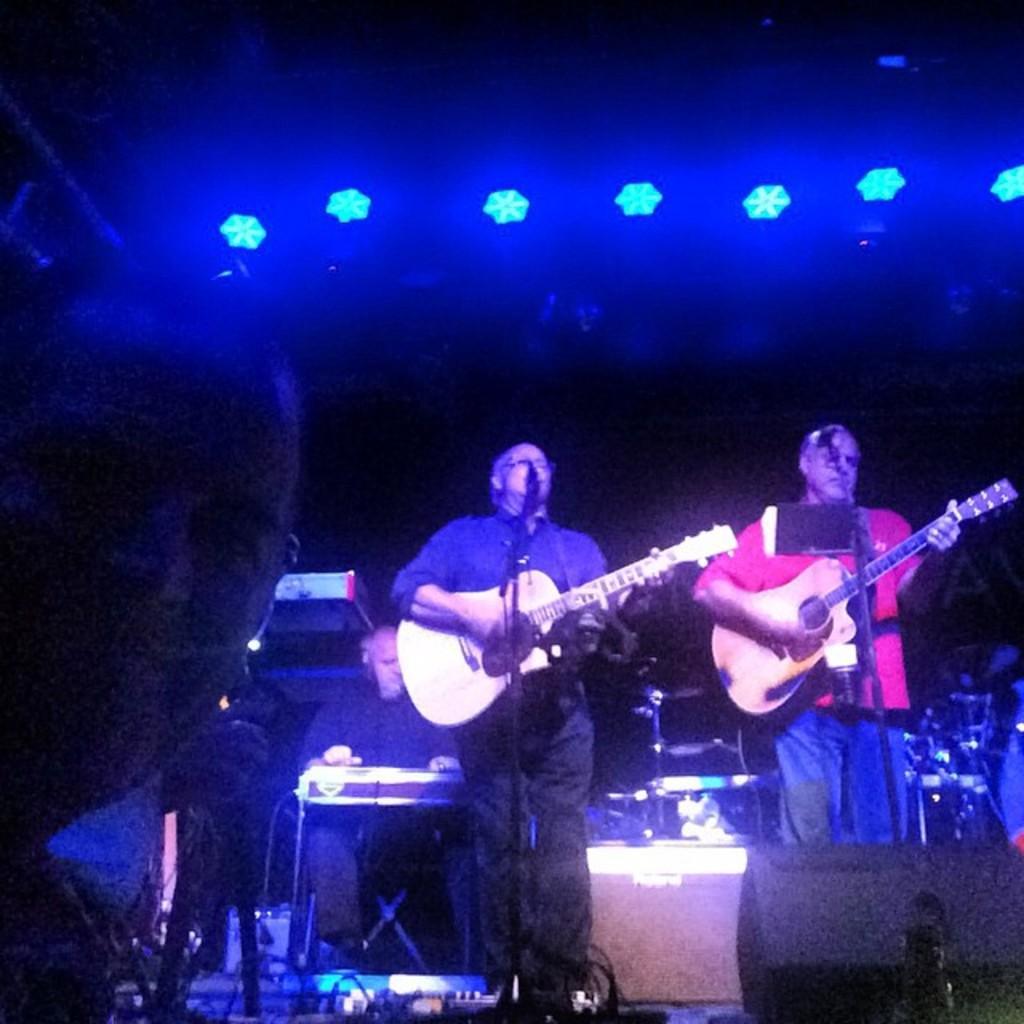Describe this image in one or two sentences. In this image on the right side a person holding a guitar and wearing a red color t- shirt,in front of him there is a mike. And beside him on the middle of the image there is a person holding a guitar and wearing a blue color shirt ,in front of him there is a guitar and wearing a spectacles. And back side of blue color shirt man there is a person sitting on the chair and playing a music. And the left corner there is a person stand on the floor. On the floor there are some lights visible. 